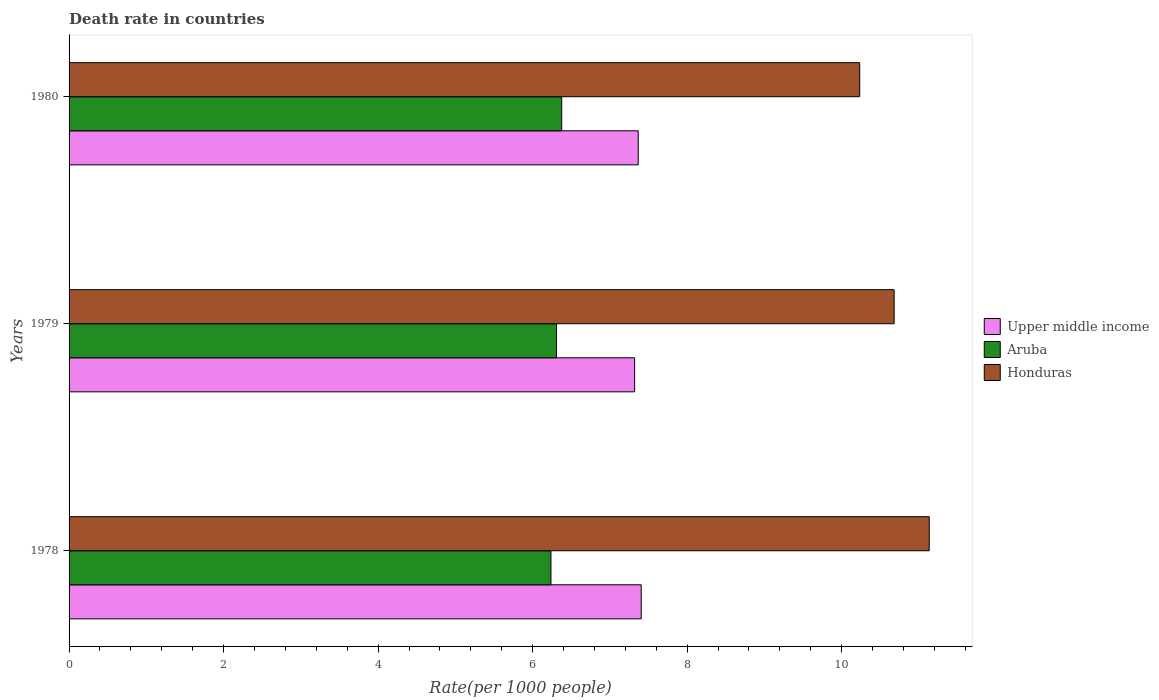Are the number of bars per tick equal to the number of legend labels?
Ensure brevity in your answer.  Yes. Are the number of bars on each tick of the Y-axis equal?
Provide a short and direct response. Yes. How many bars are there on the 1st tick from the top?
Keep it short and to the point. 3. What is the death rate in Honduras in 1979?
Your answer should be compact. 10.68. Across all years, what is the maximum death rate in Aruba?
Your answer should be compact. 6.38. Across all years, what is the minimum death rate in Upper middle income?
Make the answer very short. 7.32. In which year was the death rate in Upper middle income maximum?
Offer a very short reply. 1978. In which year was the death rate in Honduras minimum?
Make the answer very short. 1980. What is the total death rate in Aruba in the graph?
Provide a short and direct response. 18.92. What is the difference between the death rate in Upper middle income in 1979 and that in 1980?
Offer a very short reply. -0.05. What is the difference between the death rate in Honduras in 1980 and the death rate in Aruba in 1979?
Ensure brevity in your answer.  3.92. What is the average death rate in Upper middle income per year?
Your answer should be compact. 7.36. In the year 1978, what is the difference between the death rate in Upper middle income and death rate in Aruba?
Your answer should be very brief. 1.17. In how many years, is the death rate in Upper middle income greater than 4 ?
Make the answer very short. 3. What is the ratio of the death rate in Upper middle income in 1978 to that in 1979?
Offer a very short reply. 1.01. Is the difference between the death rate in Upper middle income in 1978 and 1979 greater than the difference between the death rate in Aruba in 1978 and 1979?
Offer a terse response. Yes. What is the difference between the highest and the second highest death rate in Aruba?
Your answer should be very brief. 0.07. What is the difference between the highest and the lowest death rate in Upper middle income?
Your answer should be compact. 0.09. In how many years, is the death rate in Honduras greater than the average death rate in Honduras taken over all years?
Offer a terse response. 1. What does the 3rd bar from the top in 1980 represents?
Offer a very short reply. Upper middle income. What does the 2nd bar from the bottom in 1979 represents?
Make the answer very short. Aruba. How many bars are there?
Give a very brief answer. 9. What is the difference between two consecutive major ticks on the X-axis?
Make the answer very short. 2. Are the values on the major ticks of X-axis written in scientific E-notation?
Give a very brief answer. No. Does the graph contain grids?
Provide a short and direct response. No. How many legend labels are there?
Provide a short and direct response. 3. What is the title of the graph?
Give a very brief answer. Death rate in countries. Does "Greenland" appear as one of the legend labels in the graph?
Your answer should be very brief. No. What is the label or title of the X-axis?
Your answer should be very brief. Rate(per 1000 people). What is the label or title of the Y-axis?
Offer a very short reply. Years. What is the Rate(per 1000 people) of Upper middle income in 1978?
Keep it short and to the point. 7.41. What is the Rate(per 1000 people) of Aruba in 1978?
Give a very brief answer. 6.24. What is the Rate(per 1000 people) in Honduras in 1978?
Your response must be concise. 11.13. What is the Rate(per 1000 people) in Upper middle income in 1979?
Provide a succinct answer. 7.32. What is the Rate(per 1000 people) of Aruba in 1979?
Make the answer very short. 6.31. What is the Rate(per 1000 people) of Honduras in 1979?
Offer a very short reply. 10.68. What is the Rate(per 1000 people) in Upper middle income in 1980?
Offer a very short reply. 7.37. What is the Rate(per 1000 people) of Aruba in 1980?
Offer a terse response. 6.38. What is the Rate(per 1000 people) in Honduras in 1980?
Offer a terse response. 10.23. Across all years, what is the maximum Rate(per 1000 people) in Upper middle income?
Offer a very short reply. 7.41. Across all years, what is the maximum Rate(per 1000 people) of Aruba?
Provide a short and direct response. 6.38. Across all years, what is the maximum Rate(per 1000 people) in Honduras?
Provide a short and direct response. 11.13. Across all years, what is the minimum Rate(per 1000 people) in Upper middle income?
Offer a very short reply. 7.32. Across all years, what is the minimum Rate(per 1000 people) in Aruba?
Make the answer very short. 6.24. Across all years, what is the minimum Rate(per 1000 people) in Honduras?
Your answer should be compact. 10.23. What is the total Rate(per 1000 people) of Upper middle income in the graph?
Your answer should be compact. 22.09. What is the total Rate(per 1000 people) in Aruba in the graph?
Provide a short and direct response. 18.92. What is the total Rate(per 1000 people) of Honduras in the graph?
Provide a succinct answer. 32.05. What is the difference between the Rate(per 1000 people) in Upper middle income in 1978 and that in 1979?
Make the answer very short. 0.09. What is the difference between the Rate(per 1000 people) of Aruba in 1978 and that in 1979?
Provide a short and direct response. -0.07. What is the difference between the Rate(per 1000 people) of Honduras in 1978 and that in 1979?
Your answer should be very brief. 0.45. What is the difference between the Rate(per 1000 people) in Upper middle income in 1978 and that in 1980?
Give a very brief answer. 0.04. What is the difference between the Rate(per 1000 people) of Aruba in 1978 and that in 1980?
Ensure brevity in your answer.  -0.14. What is the difference between the Rate(per 1000 people) of Upper middle income in 1979 and that in 1980?
Your response must be concise. -0.05. What is the difference between the Rate(per 1000 people) in Aruba in 1979 and that in 1980?
Keep it short and to the point. -0.07. What is the difference between the Rate(per 1000 people) in Honduras in 1979 and that in 1980?
Provide a short and direct response. 0.45. What is the difference between the Rate(per 1000 people) of Upper middle income in 1978 and the Rate(per 1000 people) of Aruba in 1979?
Give a very brief answer. 1.1. What is the difference between the Rate(per 1000 people) in Upper middle income in 1978 and the Rate(per 1000 people) in Honduras in 1979?
Give a very brief answer. -3.27. What is the difference between the Rate(per 1000 people) in Aruba in 1978 and the Rate(per 1000 people) in Honduras in 1979?
Provide a succinct answer. -4.44. What is the difference between the Rate(per 1000 people) in Upper middle income in 1978 and the Rate(per 1000 people) in Aruba in 1980?
Your response must be concise. 1.03. What is the difference between the Rate(per 1000 people) of Upper middle income in 1978 and the Rate(per 1000 people) of Honduras in 1980?
Offer a very short reply. -2.83. What is the difference between the Rate(per 1000 people) in Aruba in 1978 and the Rate(per 1000 people) in Honduras in 1980?
Provide a succinct answer. -4. What is the difference between the Rate(per 1000 people) of Upper middle income in 1979 and the Rate(per 1000 people) of Aruba in 1980?
Your answer should be very brief. 0.94. What is the difference between the Rate(per 1000 people) of Upper middle income in 1979 and the Rate(per 1000 people) of Honduras in 1980?
Provide a succinct answer. -2.91. What is the difference between the Rate(per 1000 people) of Aruba in 1979 and the Rate(per 1000 people) of Honduras in 1980?
Offer a terse response. -3.92. What is the average Rate(per 1000 people) in Upper middle income per year?
Make the answer very short. 7.36. What is the average Rate(per 1000 people) in Aruba per year?
Your answer should be very brief. 6.31. What is the average Rate(per 1000 people) in Honduras per year?
Your response must be concise. 10.68. In the year 1978, what is the difference between the Rate(per 1000 people) in Upper middle income and Rate(per 1000 people) in Aruba?
Make the answer very short. 1.17. In the year 1978, what is the difference between the Rate(per 1000 people) of Upper middle income and Rate(per 1000 people) of Honduras?
Give a very brief answer. -3.73. In the year 1978, what is the difference between the Rate(per 1000 people) in Aruba and Rate(per 1000 people) in Honduras?
Provide a succinct answer. -4.9. In the year 1979, what is the difference between the Rate(per 1000 people) of Upper middle income and Rate(per 1000 people) of Aruba?
Provide a succinct answer. 1.01. In the year 1979, what is the difference between the Rate(per 1000 people) in Upper middle income and Rate(per 1000 people) in Honduras?
Make the answer very short. -3.36. In the year 1979, what is the difference between the Rate(per 1000 people) in Aruba and Rate(per 1000 people) in Honduras?
Give a very brief answer. -4.37. In the year 1980, what is the difference between the Rate(per 1000 people) of Upper middle income and Rate(per 1000 people) of Aruba?
Your response must be concise. 0.99. In the year 1980, what is the difference between the Rate(per 1000 people) in Upper middle income and Rate(per 1000 people) in Honduras?
Your answer should be very brief. -2.87. In the year 1980, what is the difference between the Rate(per 1000 people) in Aruba and Rate(per 1000 people) in Honduras?
Make the answer very short. -3.86. What is the ratio of the Rate(per 1000 people) of Upper middle income in 1978 to that in 1979?
Your answer should be compact. 1.01. What is the ratio of the Rate(per 1000 people) of Honduras in 1978 to that in 1979?
Offer a very short reply. 1.04. What is the ratio of the Rate(per 1000 people) in Upper middle income in 1978 to that in 1980?
Ensure brevity in your answer.  1.01. What is the ratio of the Rate(per 1000 people) of Aruba in 1978 to that in 1980?
Your response must be concise. 0.98. What is the ratio of the Rate(per 1000 people) in Honduras in 1978 to that in 1980?
Make the answer very short. 1.09. What is the ratio of the Rate(per 1000 people) of Aruba in 1979 to that in 1980?
Give a very brief answer. 0.99. What is the ratio of the Rate(per 1000 people) in Honduras in 1979 to that in 1980?
Provide a succinct answer. 1.04. What is the difference between the highest and the second highest Rate(per 1000 people) of Upper middle income?
Offer a terse response. 0.04. What is the difference between the highest and the second highest Rate(per 1000 people) of Aruba?
Offer a very short reply. 0.07. What is the difference between the highest and the second highest Rate(per 1000 people) in Honduras?
Give a very brief answer. 0.45. What is the difference between the highest and the lowest Rate(per 1000 people) in Upper middle income?
Offer a very short reply. 0.09. What is the difference between the highest and the lowest Rate(per 1000 people) of Aruba?
Keep it short and to the point. 0.14. 